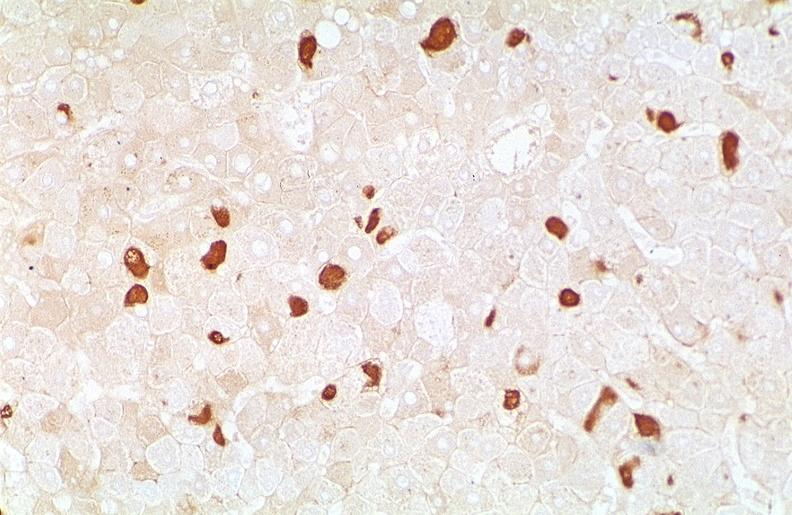s villous adenoma present?
Answer the question using a single word or phrase. No 